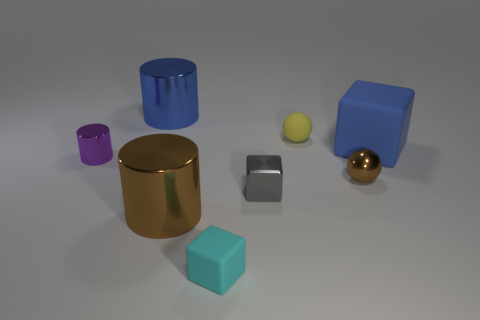Add 2 large cyan blocks. How many objects exist? 10 Subtract all brown spheres. How many spheres are left? 1 Subtract all purple metal cylinders. How many cylinders are left? 2 Subtract all cylinders. How many objects are left? 5 Subtract all gray cubes. Subtract all red cylinders. How many cubes are left? 2 Subtract all brown spheres. How many red blocks are left? 0 Subtract all cylinders. Subtract all tiny yellow things. How many objects are left? 4 Add 4 gray things. How many gray things are left? 5 Add 4 tiny rubber balls. How many tiny rubber balls exist? 5 Subtract 0 purple spheres. How many objects are left? 8 